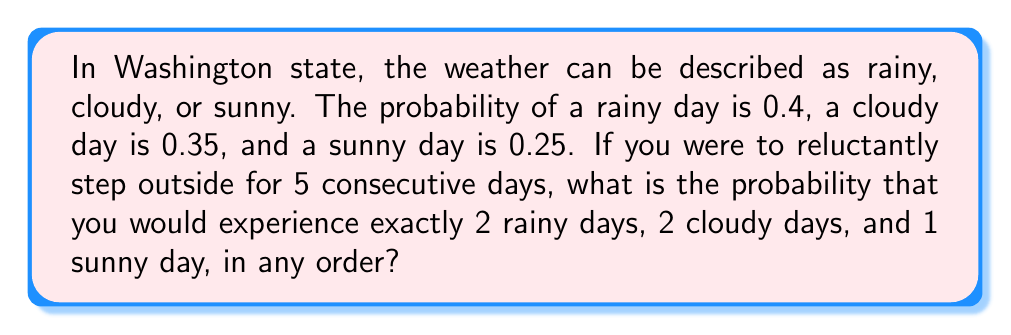Teach me how to tackle this problem. Let's approach this step-by-step:

1) This scenario follows a multinomial distribution, where we have 5 trials (days) and 3 possible outcomes (rainy, cloudy, sunny) with their respective probabilities.

2) The probability of this specific combination occurring is given by the multinomial probability formula:

   $$P(X_1 = x_1, X_2 = x_2, X_3 = x_3) = \frac{n!}{x_1! x_2! x_3!} p_1^{x_1} p_2^{x_2} p_3^{x_3}$$

   Where:
   $n$ is the total number of trials (5 days)
   $x_1, x_2, x_3$ are the number of occurrences of each outcome (2, 2, 1)
   $p_1, p_2, p_3$ are the probabilities of each outcome (0.4, 0.35, 0.25)

3) Plugging in our values:

   $$P(2 \text{ rainy}, 2 \text{ cloudy}, 1 \text{ sunny}) = \frac{5!}{2! 2! 1!} (0.4)^2 (0.35)^2 (0.25)^1$$

4) Simplify:
   
   $$= 30 \cdot 0.16 \cdot 0.1225 \cdot 0.25$$

5) Calculate:

   $$= 30 \cdot 0.0049 = 0.147$$

Thus, the probability is approximately 0.147 or 14.7%.
Answer: 0.147 